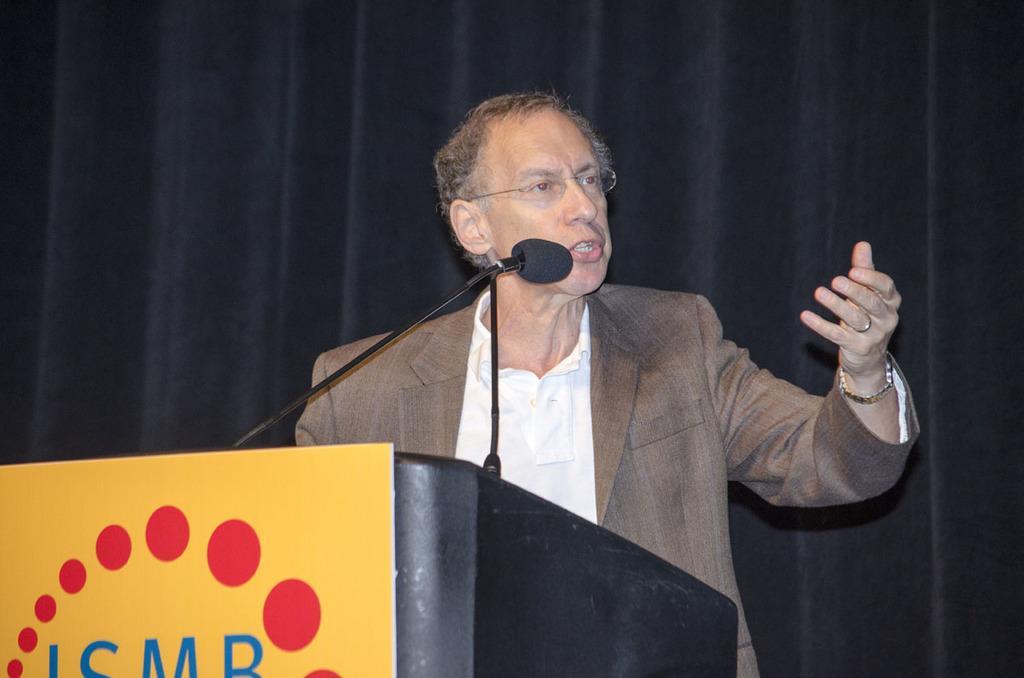Who is present in the image? There is a man in the image. What object is in front of the man? There is a microphone in front of the man. What piece of furniture is in the image? There is a desk in the image. What can be seen in the background of the image? There is a black curtain in the background of the image. What type of suit is the man wearing in the image? The image does not show the man wearing a suit, so it cannot be determined from the image. 